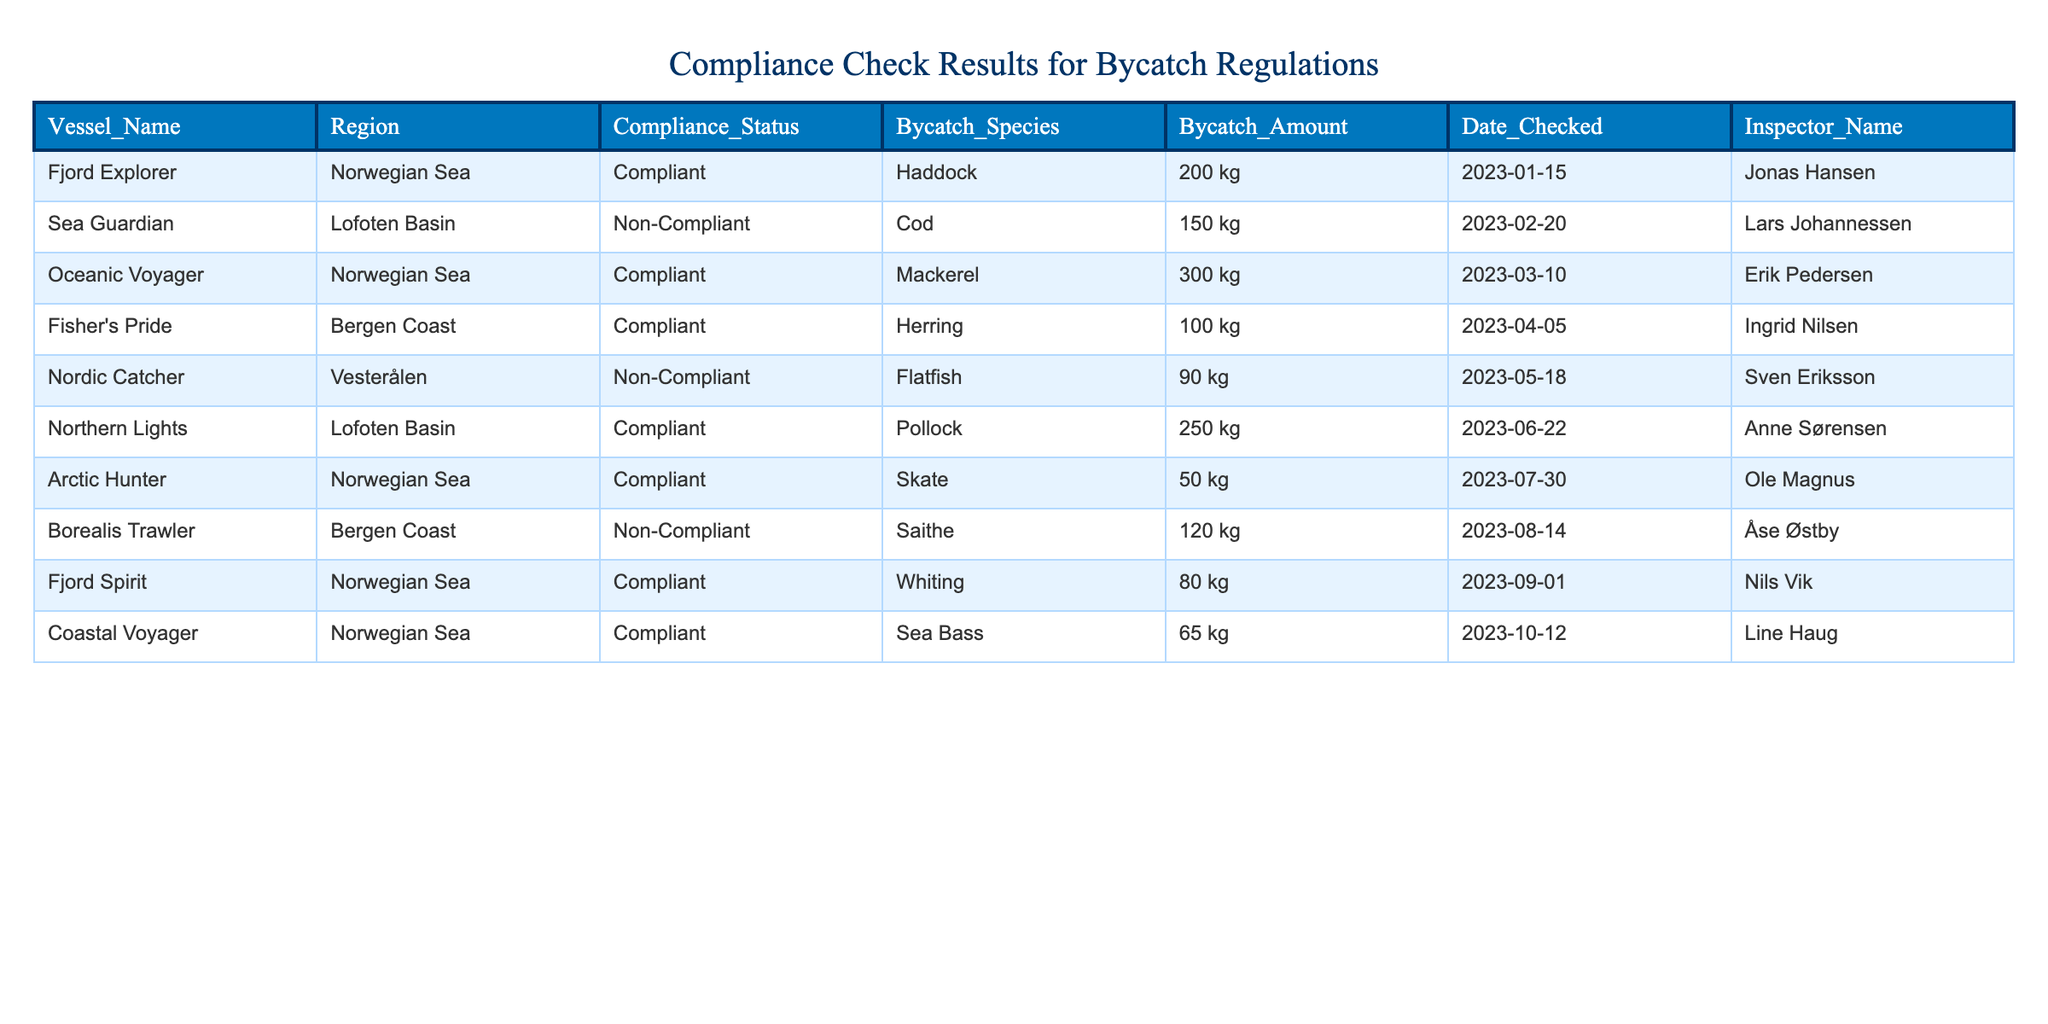What vessel was checked for compliance on 2023-02-20? The table shows the Date Checked column, which indicates that on 2023-02-20, the vessel checked was Sea Guardian.
Answer: Sea Guardian How many kilograms of bycatch were reported for the compliant vessel "Fjord Explorer"? According to the table, the bycatch amount for the compliant vessel "Fjord Explorer" is found in the Bycatch Amount column as 200 kg.
Answer: 200 kg What is the total amount of bycatch reported for non-compliant vessels? To find the total for non-compliant vessels, we look at the Bycatch Amount column for those vessels. Sea Guardian had 150 kg and Nordic Catcher had 90 kg, and Borealis Trawler had 120 kg. Summing these gives us 150 + 90 + 120 = 360 kg.
Answer: 360 kg How many vessels were compliant in the Lofoten Basin? The table lists Lofoten Basin vessels, indicating that there are two entries: Sea Guardian (non-compliant) and Northern Lights (compliant). Therefore, only Northern Lights counts as compliant.
Answer: 1 Is it true that all vessels checked in the Norwegian Sea were compliant? In examining the rows, we see that Fjord Explorer, Oceanic Voyager, Arctic Hunter, and Fjord Spirit are compliant, but there is no non-compliant vessel for this area listed. Therefore, the statement is true as all entries in the table for this region are compliant.
Answer: Yes Which inspector checked the most vessels? By analyzing the Inspector Name column for occurrences, we find that Jonas Hansen checked 1 vessel, Lars Johannessen checked 1 vessel, Erik Pedersen checked 1 vessel, Ingrid Nilsen checked 1 vessel, Sven Eriksson checked 1 vessel, Åse Østby checked 1 vessel, Anne Sørensen checked 1 vessel, Ole Magnus checked 1 vessel, and Nils Vik checked 1 vessel. Thus, all inspectors checked an equal number of vessels, one each.
Answer: None (they all checked 1) How many kilograms of bycatch were reported for compliant vessels in the Bergen Coast? Reviewing the table, the compliant vessels in the Bergen Coast (Fisher's Pride) had a reported bycatch of 100 kg. There is one entry under this category, so the total remains 100 kg.
Answer: 100 kg What is the average bycatch amount for compliant vessels across all regions? For compliant vessels: Fjord Explorer (200 kg), Oceanic Voyager (300 kg), Fisher's Pride (100 kg), Northern Lights (250 kg), Arctic Hunter (50 kg), and Fjord Spirit (80 kg) gives us a total of 1,080 kg. The number of compliant vessels is 6. Thus, the average is 1,080 / 6 = 180 kg.
Answer: 180 kg 